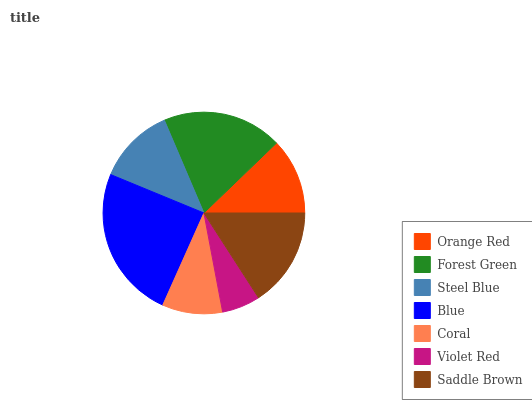Is Violet Red the minimum?
Answer yes or no. Yes. Is Blue the maximum?
Answer yes or no. Yes. Is Forest Green the minimum?
Answer yes or no. No. Is Forest Green the maximum?
Answer yes or no. No. Is Forest Green greater than Orange Red?
Answer yes or no. Yes. Is Orange Red less than Forest Green?
Answer yes or no. Yes. Is Orange Red greater than Forest Green?
Answer yes or no. No. Is Forest Green less than Orange Red?
Answer yes or no. No. Is Steel Blue the high median?
Answer yes or no. Yes. Is Steel Blue the low median?
Answer yes or no. Yes. Is Coral the high median?
Answer yes or no. No. Is Saddle Brown the low median?
Answer yes or no. No. 